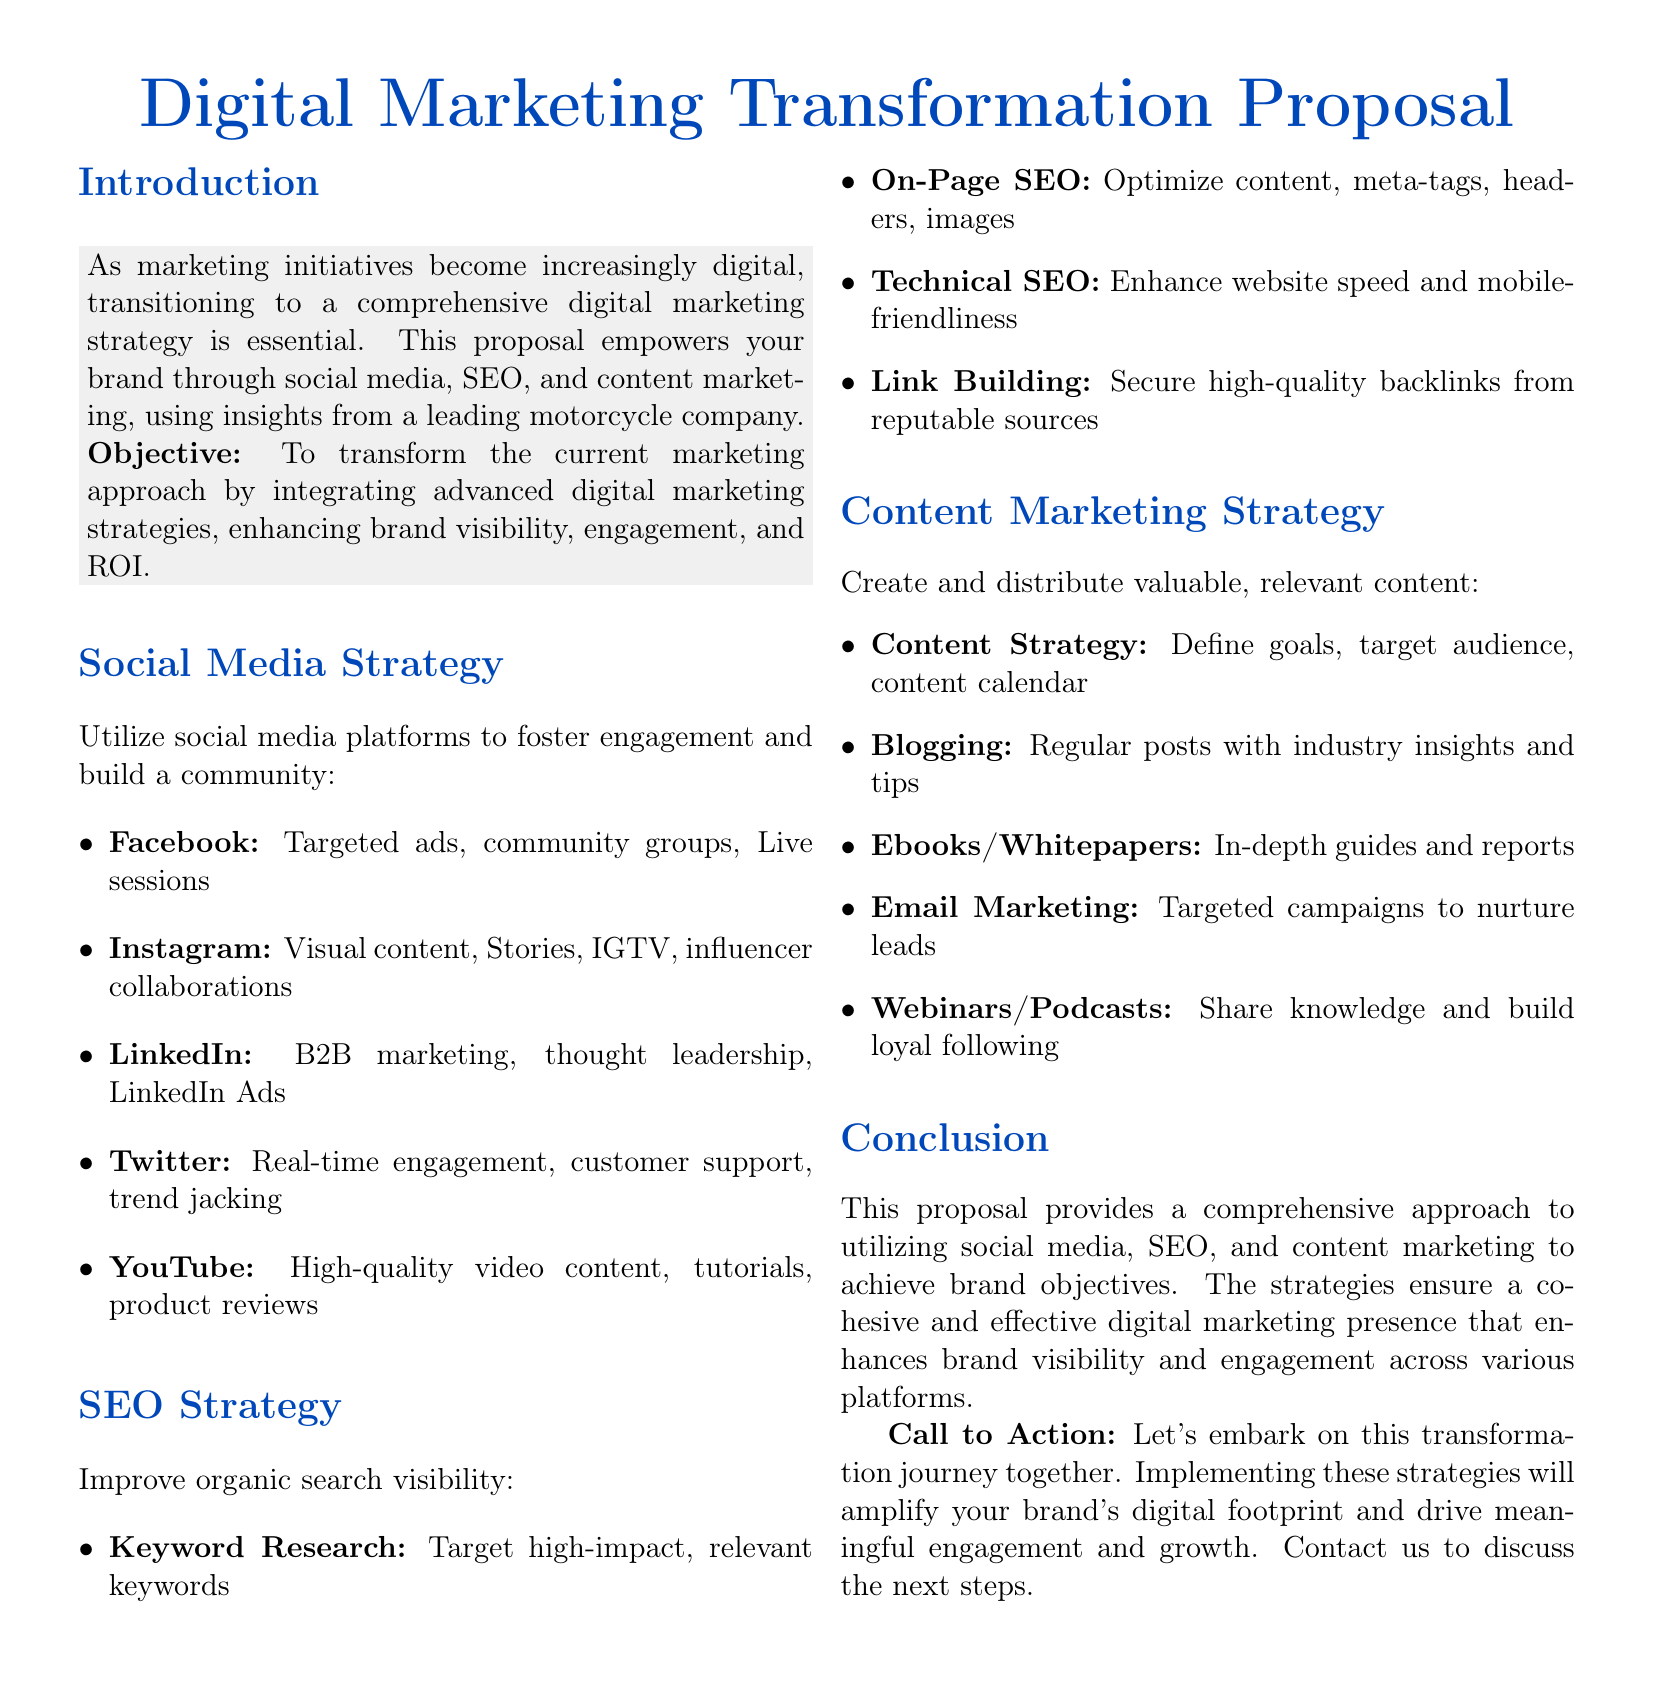What is the main objective of the proposal? The objective is to transform the current marketing approach by integrating advanced digital marketing strategies.
Answer: Transform the current marketing approach Which social media platform is suggested for B2B marketing? LinkedIn is mentioned specifically for B2B marketing initiatives in the document.
Answer: LinkedIn What type of content is emphasized in the Instagram strategy? The document suggests using visual content, Stories, IGTV, and influencer collaborations on Instagram.
Answer: Visual content How many strategies are outlined for SEO improvement? The document lists four specific strategies under the SEO section.
Answer: Four What type of content is recommended for nurturing leads? Email marketing is recommended for targeted campaigns to nurture leads.
Answer: Email marketing Which type of document is this? The document is a proposal that outlines strategies for digital marketing transformation.
Answer: Proposal What is one method suggested for enhancing website performance? The document mentions enhancing website speed and mobile-friendliness as part of the technical SEO strategy.
Answer: Technical SEO What call to action is included in the conclusion? The proposal includes a call to action encouraging potential clients to discuss the next steps for implementation.
Answer: Discuss the next steps 